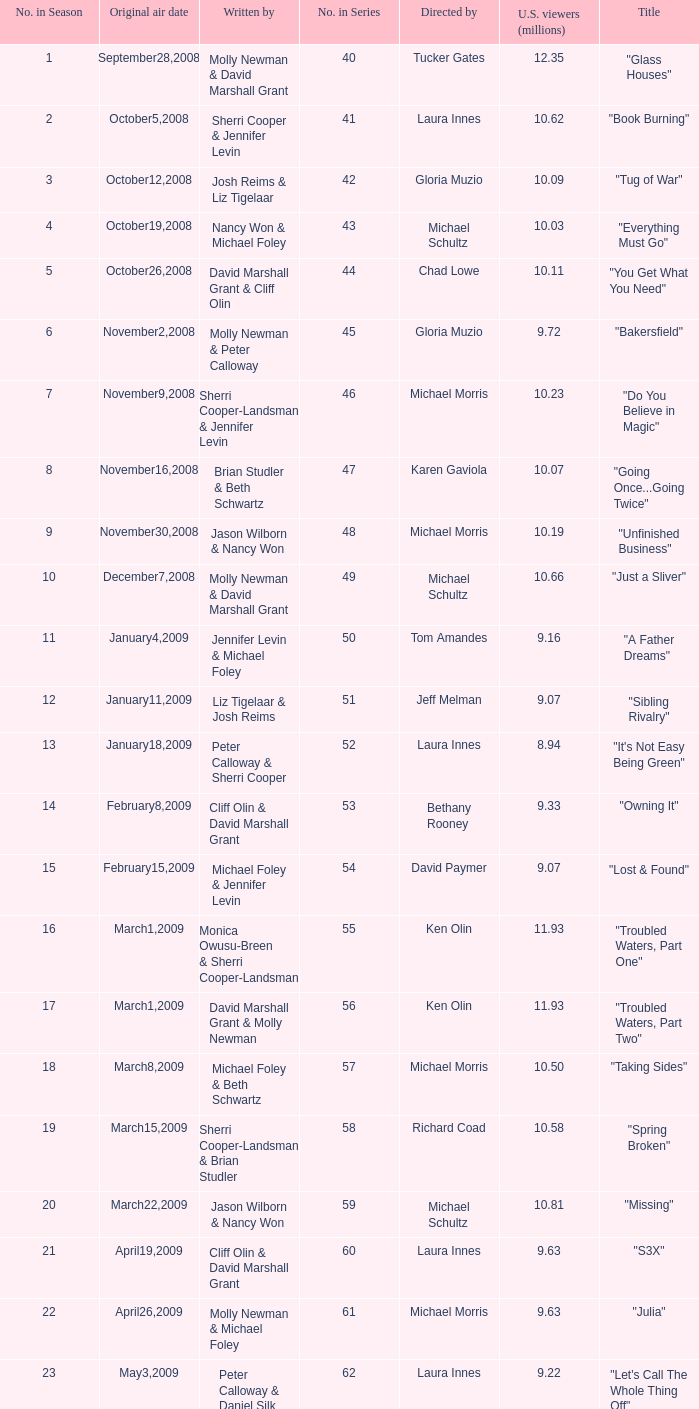What's the name of the episode seen by 9.63 millions of people in the US, whose director is Laura Innes? "S3X". 